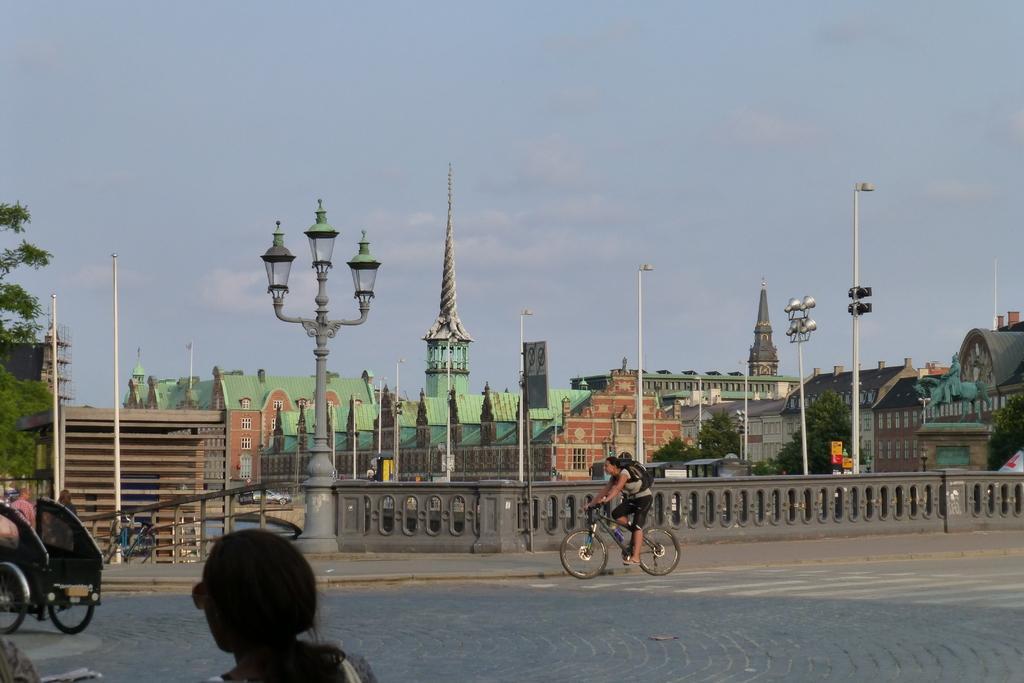Can you describe this image briefly? This is an outside view. At the bottom there is a road and I can see a person's head. On the left side there is a cart. In the middle of the image there is a person riding the bicycle on the road. In the background there are many buildings, poles and trees. At the top of the image I can see the sky. 